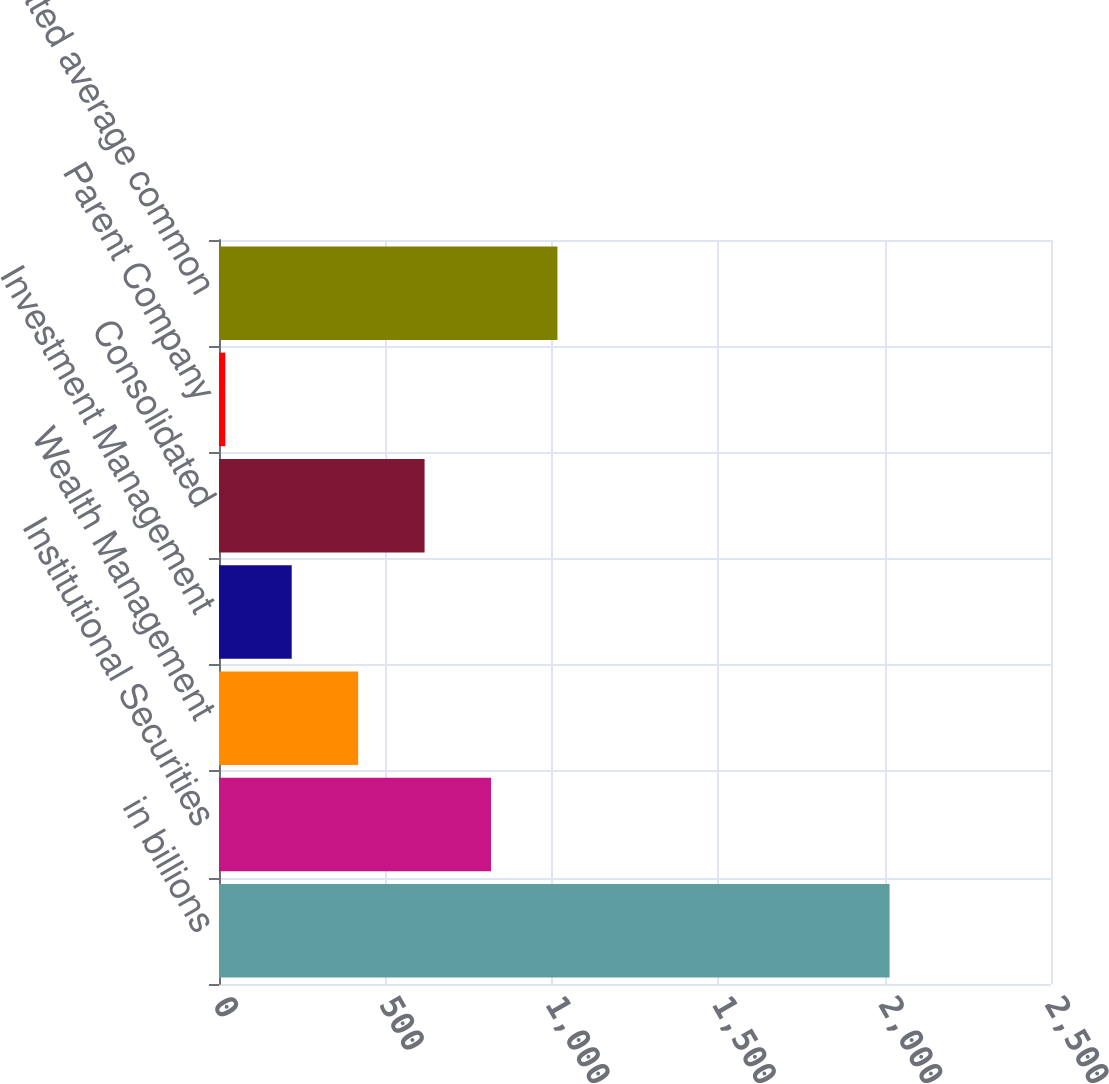Convert chart. <chart><loc_0><loc_0><loc_500><loc_500><bar_chart><fcel>in billions<fcel>Institutional Securities<fcel>Wealth Management<fcel>Investment Management<fcel>Consolidated<fcel>Parent Company<fcel>Consolidated average common<nl><fcel>2015<fcel>817.34<fcel>418.12<fcel>218.51<fcel>617.73<fcel>18.9<fcel>1016.95<nl></chart> 